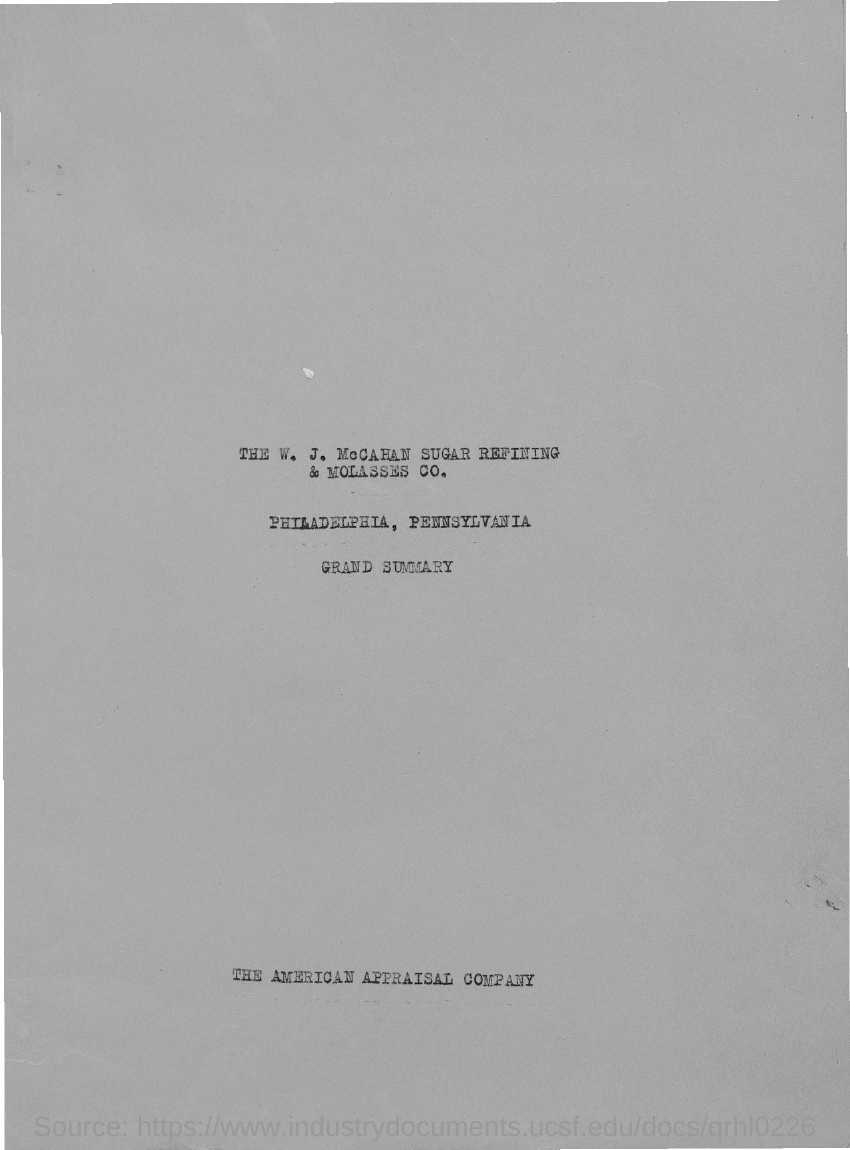What is the title at the end of the document?
Make the answer very short. The American Appraisal Company. 